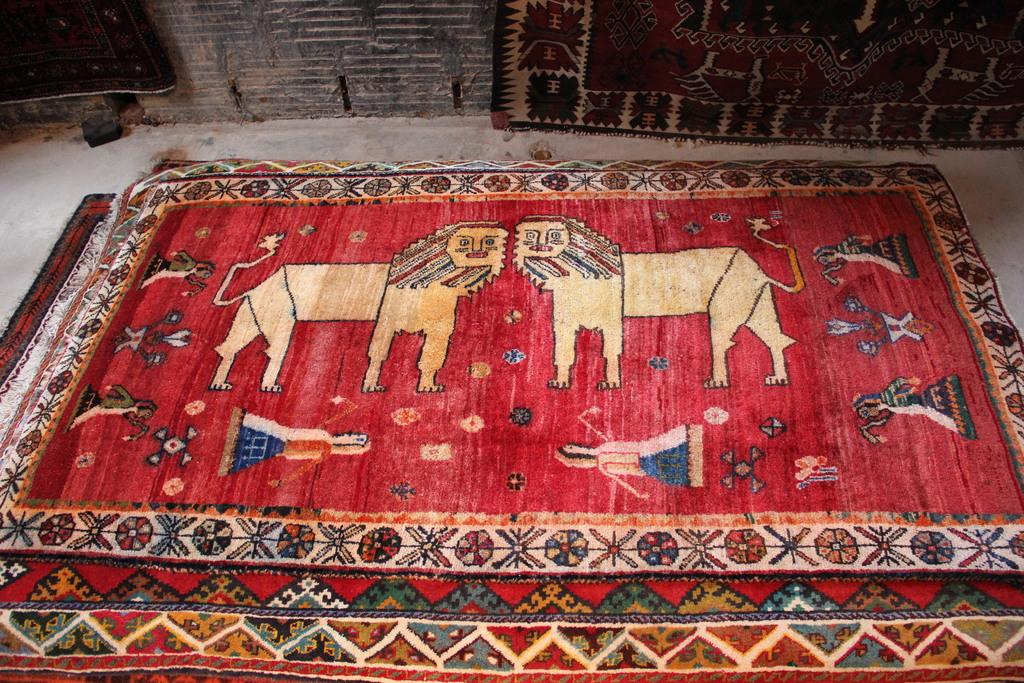What type of flooring is present in the image? There are carpets on the floor. Are there any carpets on the wall? Yes, there are carpets on the wall. How many chairs can be seen in the image? There are no chairs present in the image; it only features carpets on the floor and wall. 